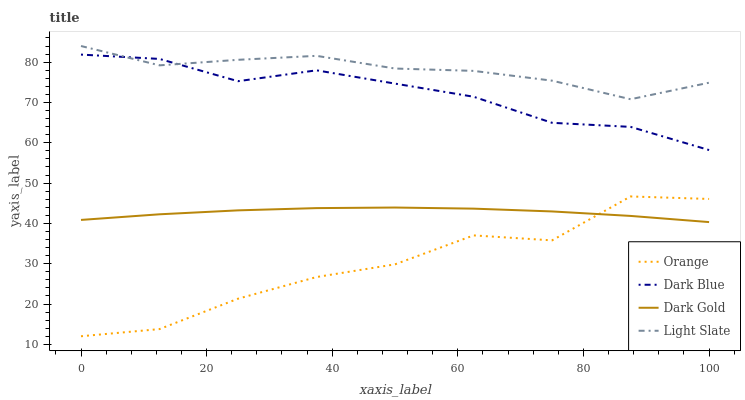Does Orange have the minimum area under the curve?
Answer yes or no. Yes. Does Light Slate have the maximum area under the curve?
Answer yes or no. Yes. Does Dark Blue have the minimum area under the curve?
Answer yes or no. No. Does Dark Blue have the maximum area under the curve?
Answer yes or no. No. Is Dark Gold the smoothest?
Answer yes or no. Yes. Is Orange the roughest?
Answer yes or no. Yes. Is Dark Blue the smoothest?
Answer yes or no. No. Is Dark Blue the roughest?
Answer yes or no. No. Does Orange have the lowest value?
Answer yes or no. Yes. Does Dark Blue have the lowest value?
Answer yes or no. No. Does Light Slate have the highest value?
Answer yes or no. Yes. Does Dark Blue have the highest value?
Answer yes or no. No. Is Dark Gold less than Dark Blue?
Answer yes or no. Yes. Is Light Slate greater than Orange?
Answer yes or no. Yes. Does Orange intersect Dark Gold?
Answer yes or no. Yes. Is Orange less than Dark Gold?
Answer yes or no. No. Is Orange greater than Dark Gold?
Answer yes or no. No. Does Dark Gold intersect Dark Blue?
Answer yes or no. No. 